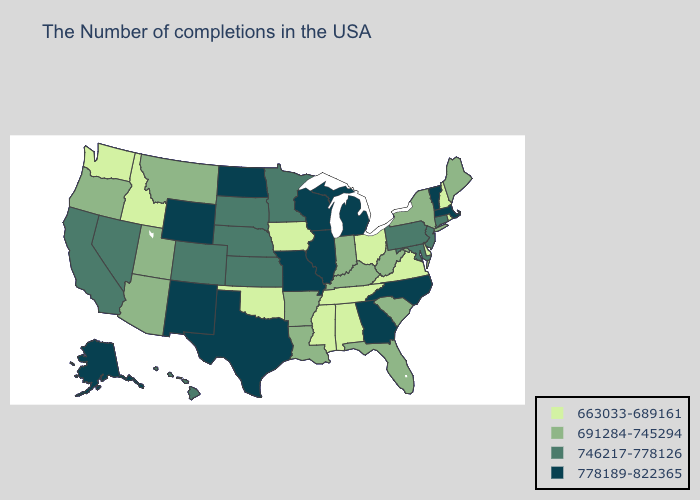Among the states that border Texas , does Louisiana have the lowest value?
Keep it brief. No. What is the value of Alabama?
Keep it brief. 663033-689161. What is the lowest value in states that border Florida?
Answer briefly. 663033-689161. Among the states that border Indiana , does Michigan have the lowest value?
Answer briefly. No. Name the states that have a value in the range 663033-689161?
Write a very short answer. Rhode Island, New Hampshire, Delaware, Virginia, Ohio, Alabama, Tennessee, Mississippi, Iowa, Oklahoma, Idaho, Washington. What is the highest value in the West ?
Answer briefly. 778189-822365. Which states have the lowest value in the Northeast?
Write a very short answer. Rhode Island, New Hampshire. Is the legend a continuous bar?
Answer briefly. No. Name the states that have a value in the range 691284-745294?
Write a very short answer. Maine, New York, South Carolina, West Virginia, Florida, Kentucky, Indiana, Louisiana, Arkansas, Utah, Montana, Arizona, Oregon. Which states have the lowest value in the South?
Give a very brief answer. Delaware, Virginia, Alabama, Tennessee, Mississippi, Oklahoma. Among the states that border Iowa , does Illinois have the highest value?
Be succinct. Yes. Does Maryland have a lower value than North Carolina?
Quick response, please. Yes. Does Alabama have the lowest value in the USA?
Concise answer only. Yes. Is the legend a continuous bar?
Answer briefly. No. What is the lowest value in the USA?
Be succinct. 663033-689161. 